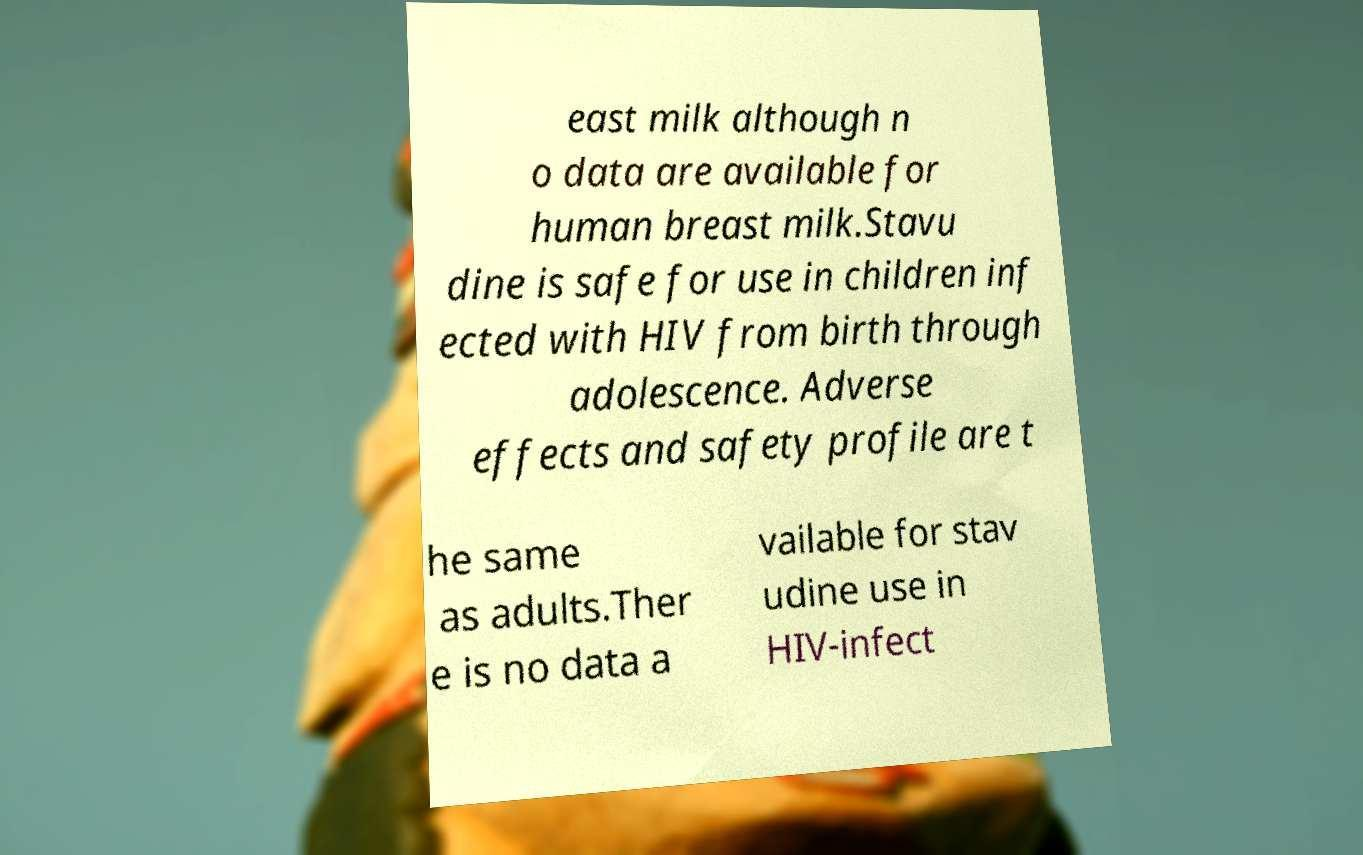Please read and relay the text visible in this image. What does it say? east milk although n o data are available for human breast milk.Stavu dine is safe for use in children inf ected with HIV from birth through adolescence. Adverse effects and safety profile are t he same as adults.Ther e is no data a vailable for stav udine use in HIV-infect 